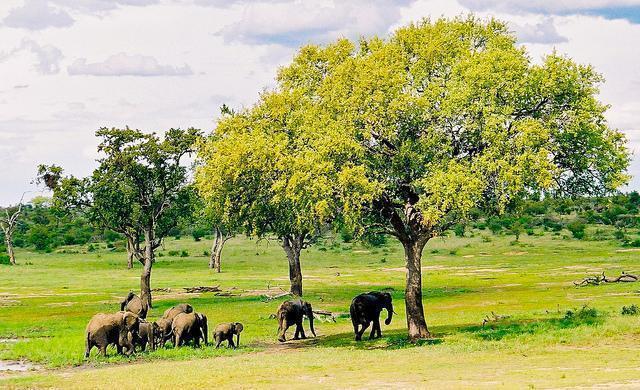How many elephants are there to lead this herd?
From the following set of four choices, select the accurate answer to respond to the question.
Options: Four, three, two, one. Two. 